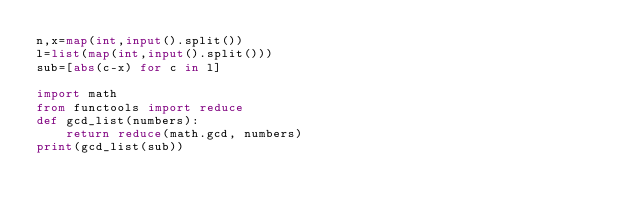<code> <loc_0><loc_0><loc_500><loc_500><_Python_>n,x=map(int,input().split())
l=list(map(int,input().split()))
sub=[abs(c-x) for c in l]

import math
from functools import reduce
def gcd_list(numbers):
    return reduce(math.gcd, numbers)
print(gcd_list(sub))</code> 